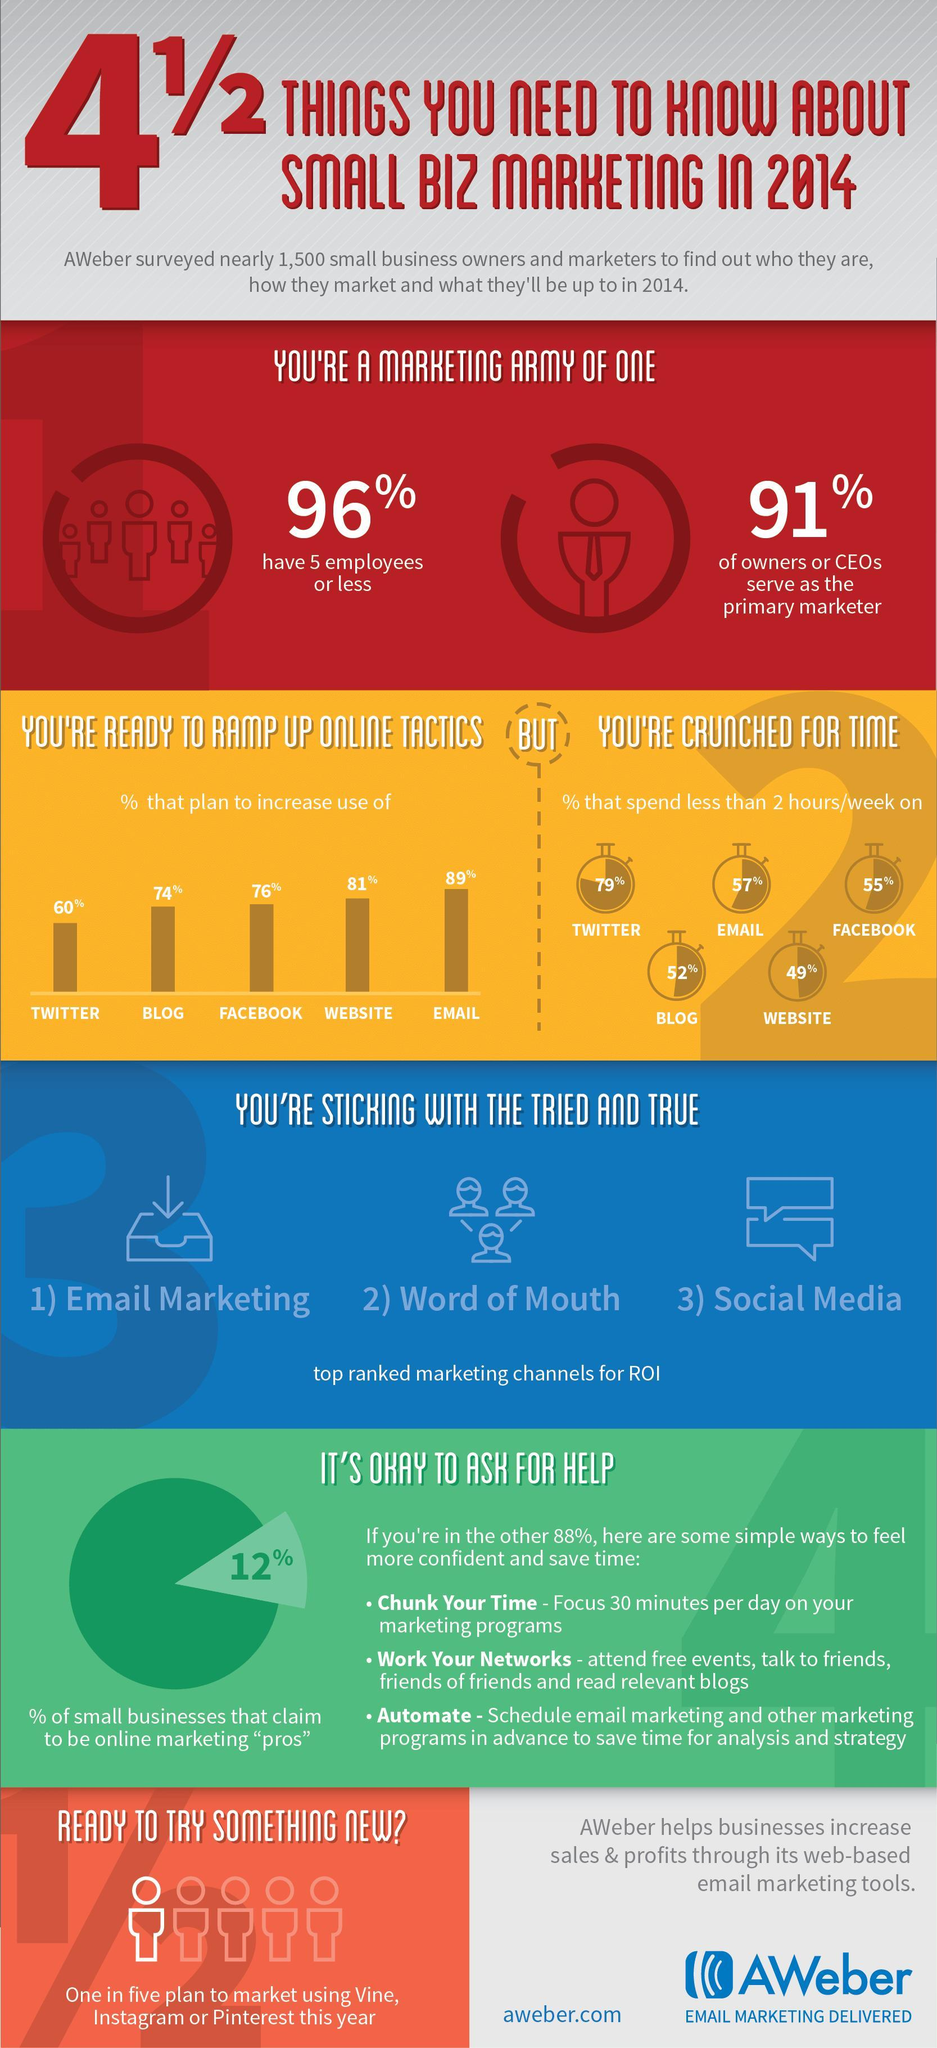What percentage of small business owners & marketers plan to increase the use of Facebook as a part of online marketing tactics in 2014?
Answer the question with a short phrase. 76% What percentage of small business owners & marketers plan to increase the use of Twitter as a part of online marketing tactics in 2014 according to the survey? 60% What percentage of small business owners & marketers plan to increase the use of Website as a part of online marketing tactics in 2014? 81% What percentage of respondents spend less than 2 hours per week on blogs in 2014 as per the survey? 52% What percentage of respondents spend less than 2 hours per week on emails in 2014 as per the survey? 57% 